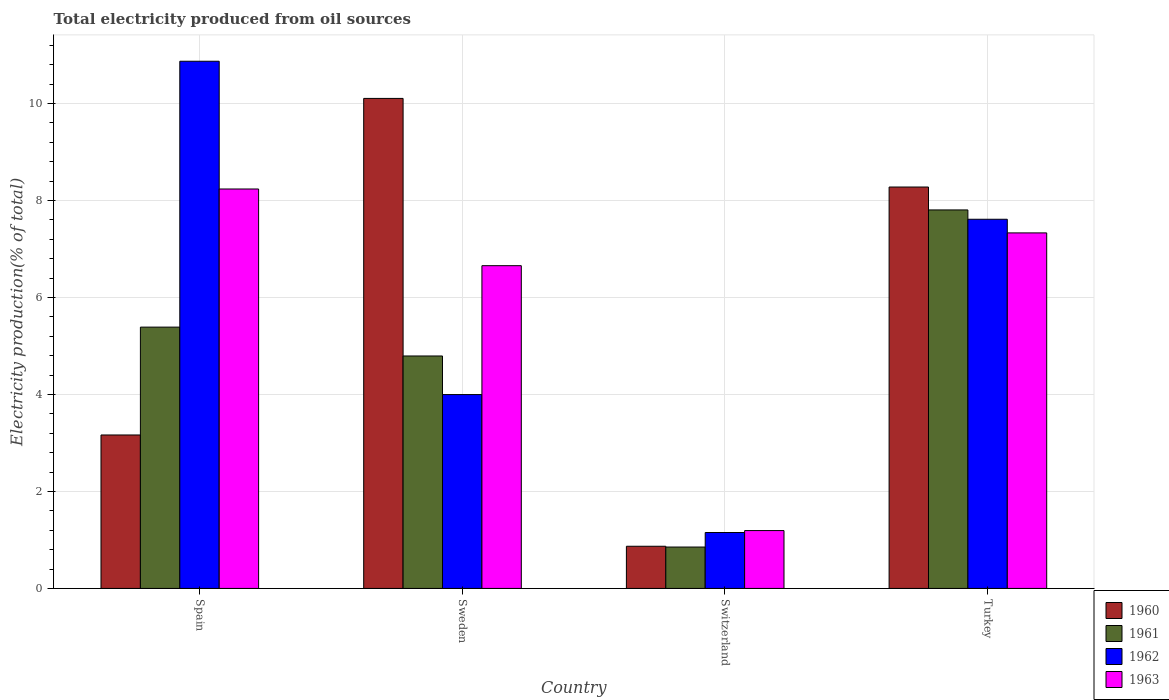How many different coloured bars are there?
Make the answer very short. 4. How many groups of bars are there?
Your answer should be compact. 4. How many bars are there on the 1st tick from the left?
Your response must be concise. 4. How many bars are there on the 3rd tick from the right?
Give a very brief answer. 4. What is the label of the 3rd group of bars from the left?
Make the answer very short. Switzerland. What is the total electricity produced in 1960 in Sweden?
Your answer should be very brief. 10.1. Across all countries, what is the maximum total electricity produced in 1961?
Provide a short and direct response. 7.8. Across all countries, what is the minimum total electricity produced in 1963?
Offer a terse response. 1.19. In which country was the total electricity produced in 1963 minimum?
Offer a terse response. Switzerland. What is the total total electricity produced in 1963 in the graph?
Provide a succinct answer. 23.42. What is the difference between the total electricity produced in 1962 in Spain and that in Turkey?
Ensure brevity in your answer.  3.26. What is the difference between the total electricity produced in 1960 in Switzerland and the total electricity produced in 1963 in Spain?
Your answer should be very brief. -7.37. What is the average total electricity produced in 1960 per country?
Your answer should be very brief. 5.6. What is the difference between the total electricity produced of/in 1962 and total electricity produced of/in 1963 in Turkey?
Your answer should be compact. 0.28. In how many countries, is the total electricity produced in 1962 greater than 4.4 %?
Provide a short and direct response. 2. What is the ratio of the total electricity produced in 1962 in Sweden to that in Switzerland?
Your answer should be very brief. 3.47. What is the difference between the highest and the second highest total electricity produced in 1961?
Give a very brief answer. -0.6. What is the difference between the highest and the lowest total electricity produced in 1960?
Your answer should be very brief. 9.23. In how many countries, is the total electricity produced in 1960 greater than the average total electricity produced in 1960 taken over all countries?
Provide a short and direct response. 2. What does the 4th bar from the left in Sweden represents?
Give a very brief answer. 1963. Is it the case that in every country, the sum of the total electricity produced in 1962 and total electricity produced in 1963 is greater than the total electricity produced in 1961?
Your answer should be compact. Yes. What is the difference between two consecutive major ticks on the Y-axis?
Provide a succinct answer. 2. Where does the legend appear in the graph?
Your answer should be very brief. Bottom right. How many legend labels are there?
Offer a very short reply. 4. How are the legend labels stacked?
Offer a terse response. Vertical. What is the title of the graph?
Provide a succinct answer. Total electricity produced from oil sources. Does "2002" appear as one of the legend labels in the graph?
Ensure brevity in your answer.  No. What is the Electricity production(% of total) of 1960 in Spain?
Your response must be concise. 3.16. What is the Electricity production(% of total) of 1961 in Spain?
Provide a succinct answer. 5.39. What is the Electricity production(% of total) in 1962 in Spain?
Your response must be concise. 10.87. What is the Electricity production(% of total) of 1963 in Spain?
Offer a terse response. 8.24. What is the Electricity production(% of total) in 1960 in Sweden?
Give a very brief answer. 10.1. What is the Electricity production(% of total) of 1961 in Sweden?
Offer a very short reply. 4.79. What is the Electricity production(% of total) in 1962 in Sweden?
Keep it short and to the point. 4. What is the Electricity production(% of total) in 1963 in Sweden?
Your answer should be very brief. 6.66. What is the Electricity production(% of total) in 1960 in Switzerland?
Provide a short and direct response. 0.87. What is the Electricity production(% of total) of 1961 in Switzerland?
Provide a succinct answer. 0.85. What is the Electricity production(% of total) in 1962 in Switzerland?
Ensure brevity in your answer.  1.15. What is the Electricity production(% of total) of 1963 in Switzerland?
Your answer should be compact. 1.19. What is the Electricity production(% of total) in 1960 in Turkey?
Offer a terse response. 8.28. What is the Electricity production(% of total) of 1961 in Turkey?
Your response must be concise. 7.8. What is the Electricity production(% of total) of 1962 in Turkey?
Your answer should be very brief. 7.61. What is the Electricity production(% of total) in 1963 in Turkey?
Your answer should be compact. 7.33. Across all countries, what is the maximum Electricity production(% of total) in 1960?
Provide a succinct answer. 10.1. Across all countries, what is the maximum Electricity production(% of total) of 1961?
Offer a terse response. 7.8. Across all countries, what is the maximum Electricity production(% of total) of 1962?
Your response must be concise. 10.87. Across all countries, what is the maximum Electricity production(% of total) in 1963?
Your answer should be compact. 8.24. Across all countries, what is the minimum Electricity production(% of total) in 1960?
Provide a short and direct response. 0.87. Across all countries, what is the minimum Electricity production(% of total) in 1961?
Your response must be concise. 0.85. Across all countries, what is the minimum Electricity production(% of total) of 1962?
Your answer should be compact. 1.15. Across all countries, what is the minimum Electricity production(% of total) in 1963?
Ensure brevity in your answer.  1.19. What is the total Electricity production(% of total) of 1960 in the graph?
Make the answer very short. 22.42. What is the total Electricity production(% of total) of 1961 in the graph?
Give a very brief answer. 18.84. What is the total Electricity production(% of total) of 1962 in the graph?
Offer a terse response. 23.63. What is the total Electricity production(% of total) in 1963 in the graph?
Offer a terse response. 23.42. What is the difference between the Electricity production(% of total) of 1960 in Spain and that in Sweden?
Offer a very short reply. -6.94. What is the difference between the Electricity production(% of total) of 1961 in Spain and that in Sweden?
Offer a very short reply. 0.6. What is the difference between the Electricity production(% of total) of 1962 in Spain and that in Sweden?
Your response must be concise. 6.87. What is the difference between the Electricity production(% of total) of 1963 in Spain and that in Sweden?
Ensure brevity in your answer.  1.58. What is the difference between the Electricity production(% of total) of 1960 in Spain and that in Switzerland?
Offer a very short reply. 2.29. What is the difference between the Electricity production(% of total) of 1961 in Spain and that in Switzerland?
Keep it short and to the point. 4.53. What is the difference between the Electricity production(% of total) in 1962 in Spain and that in Switzerland?
Ensure brevity in your answer.  9.72. What is the difference between the Electricity production(% of total) of 1963 in Spain and that in Switzerland?
Keep it short and to the point. 7.04. What is the difference between the Electricity production(% of total) in 1960 in Spain and that in Turkey?
Give a very brief answer. -5.11. What is the difference between the Electricity production(% of total) in 1961 in Spain and that in Turkey?
Offer a terse response. -2.42. What is the difference between the Electricity production(% of total) of 1962 in Spain and that in Turkey?
Provide a short and direct response. 3.26. What is the difference between the Electricity production(% of total) of 1963 in Spain and that in Turkey?
Your answer should be compact. 0.91. What is the difference between the Electricity production(% of total) of 1960 in Sweden and that in Switzerland?
Ensure brevity in your answer.  9.23. What is the difference between the Electricity production(% of total) of 1961 in Sweden and that in Switzerland?
Your answer should be very brief. 3.94. What is the difference between the Electricity production(% of total) of 1962 in Sweden and that in Switzerland?
Your answer should be very brief. 2.84. What is the difference between the Electricity production(% of total) in 1963 in Sweden and that in Switzerland?
Make the answer very short. 5.46. What is the difference between the Electricity production(% of total) of 1960 in Sweden and that in Turkey?
Your answer should be very brief. 1.83. What is the difference between the Electricity production(% of total) in 1961 in Sweden and that in Turkey?
Offer a very short reply. -3.01. What is the difference between the Electricity production(% of total) of 1962 in Sweden and that in Turkey?
Provide a short and direct response. -3.61. What is the difference between the Electricity production(% of total) of 1963 in Sweden and that in Turkey?
Make the answer very short. -0.68. What is the difference between the Electricity production(% of total) in 1960 in Switzerland and that in Turkey?
Ensure brevity in your answer.  -7.41. What is the difference between the Electricity production(% of total) in 1961 in Switzerland and that in Turkey?
Provide a succinct answer. -6.95. What is the difference between the Electricity production(% of total) of 1962 in Switzerland and that in Turkey?
Make the answer very short. -6.46. What is the difference between the Electricity production(% of total) in 1963 in Switzerland and that in Turkey?
Ensure brevity in your answer.  -6.14. What is the difference between the Electricity production(% of total) in 1960 in Spain and the Electricity production(% of total) in 1961 in Sweden?
Your response must be concise. -1.63. What is the difference between the Electricity production(% of total) of 1960 in Spain and the Electricity production(% of total) of 1962 in Sweden?
Provide a short and direct response. -0.83. What is the difference between the Electricity production(% of total) of 1960 in Spain and the Electricity production(% of total) of 1963 in Sweden?
Make the answer very short. -3.49. What is the difference between the Electricity production(% of total) of 1961 in Spain and the Electricity production(% of total) of 1962 in Sweden?
Your answer should be very brief. 1.39. What is the difference between the Electricity production(% of total) of 1961 in Spain and the Electricity production(% of total) of 1963 in Sweden?
Give a very brief answer. -1.27. What is the difference between the Electricity production(% of total) of 1962 in Spain and the Electricity production(% of total) of 1963 in Sweden?
Your response must be concise. 4.22. What is the difference between the Electricity production(% of total) in 1960 in Spain and the Electricity production(% of total) in 1961 in Switzerland?
Give a very brief answer. 2.31. What is the difference between the Electricity production(% of total) of 1960 in Spain and the Electricity production(% of total) of 1962 in Switzerland?
Provide a short and direct response. 2.01. What is the difference between the Electricity production(% of total) of 1960 in Spain and the Electricity production(% of total) of 1963 in Switzerland?
Offer a terse response. 1.97. What is the difference between the Electricity production(% of total) in 1961 in Spain and the Electricity production(% of total) in 1962 in Switzerland?
Ensure brevity in your answer.  4.24. What is the difference between the Electricity production(% of total) of 1961 in Spain and the Electricity production(% of total) of 1963 in Switzerland?
Keep it short and to the point. 4.2. What is the difference between the Electricity production(% of total) of 1962 in Spain and the Electricity production(% of total) of 1963 in Switzerland?
Offer a terse response. 9.68. What is the difference between the Electricity production(% of total) in 1960 in Spain and the Electricity production(% of total) in 1961 in Turkey?
Offer a very short reply. -4.64. What is the difference between the Electricity production(% of total) in 1960 in Spain and the Electricity production(% of total) in 1962 in Turkey?
Your answer should be compact. -4.45. What is the difference between the Electricity production(% of total) of 1960 in Spain and the Electricity production(% of total) of 1963 in Turkey?
Provide a succinct answer. -4.17. What is the difference between the Electricity production(% of total) in 1961 in Spain and the Electricity production(% of total) in 1962 in Turkey?
Keep it short and to the point. -2.22. What is the difference between the Electricity production(% of total) of 1961 in Spain and the Electricity production(% of total) of 1963 in Turkey?
Your response must be concise. -1.94. What is the difference between the Electricity production(% of total) of 1962 in Spain and the Electricity production(% of total) of 1963 in Turkey?
Your response must be concise. 3.54. What is the difference between the Electricity production(% of total) in 1960 in Sweden and the Electricity production(% of total) in 1961 in Switzerland?
Provide a succinct answer. 9.25. What is the difference between the Electricity production(% of total) of 1960 in Sweden and the Electricity production(% of total) of 1962 in Switzerland?
Your answer should be very brief. 8.95. What is the difference between the Electricity production(% of total) of 1960 in Sweden and the Electricity production(% of total) of 1963 in Switzerland?
Keep it short and to the point. 8.91. What is the difference between the Electricity production(% of total) of 1961 in Sweden and the Electricity production(% of total) of 1962 in Switzerland?
Keep it short and to the point. 3.64. What is the difference between the Electricity production(% of total) of 1961 in Sweden and the Electricity production(% of total) of 1963 in Switzerland?
Your answer should be compact. 3.6. What is the difference between the Electricity production(% of total) in 1962 in Sweden and the Electricity production(% of total) in 1963 in Switzerland?
Your answer should be very brief. 2.8. What is the difference between the Electricity production(% of total) in 1960 in Sweden and the Electricity production(% of total) in 1961 in Turkey?
Give a very brief answer. 2.3. What is the difference between the Electricity production(% of total) in 1960 in Sweden and the Electricity production(% of total) in 1962 in Turkey?
Give a very brief answer. 2.49. What is the difference between the Electricity production(% of total) of 1960 in Sweden and the Electricity production(% of total) of 1963 in Turkey?
Your answer should be very brief. 2.77. What is the difference between the Electricity production(% of total) in 1961 in Sweden and the Electricity production(% of total) in 1962 in Turkey?
Offer a terse response. -2.82. What is the difference between the Electricity production(% of total) in 1961 in Sweden and the Electricity production(% of total) in 1963 in Turkey?
Your answer should be very brief. -2.54. What is the difference between the Electricity production(% of total) in 1962 in Sweden and the Electricity production(% of total) in 1963 in Turkey?
Ensure brevity in your answer.  -3.33. What is the difference between the Electricity production(% of total) in 1960 in Switzerland and the Electricity production(% of total) in 1961 in Turkey?
Make the answer very short. -6.94. What is the difference between the Electricity production(% of total) of 1960 in Switzerland and the Electricity production(% of total) of 1962 in Turkey?
Keep it short and to the point. -6.74. What is the difference between the Electricity production(% of total) in 1960 in Switzerland and the Electricity production(% of total) in 1963 in Turkey?
Keep it short and to the point. -6.46. What is the difference between the Electricity production(% of total) of 1961 in Switzerland and the Electricity production(% of total) of 1962 in Turkey?
Provide a short and direct response. -6.76. What is the difference between the Electricity production(% of total) of 1961 in Switzerland and the Electricity production(% of total) of 1963 in Turkey?
Offer a very short reply. -6.48. What is the difference between the Electricity production(% of total) of 1962 in Switzerland and the Electricity production(% of total) of 1963 in Turkey?
Your response must be concise. -6.18. What is the average Electricity production(% of total) in 1960 per country?
Keep it short and to the point. 5.6. What is the average Electricity production(% of total) of 1961 per country?
Your answer should be compact. 4.71. What is the average Electricity production(% of total) of 1962 per country?
Your answer should be compact. 5.91. What is the average Electricity production(% of total) in 1963 per country?
Make the answer very short. 5.85. What is the difference between the Electricity production(% of total) of 1960 and Electricity production(% of total) of 1961 in Spain?
Keep it short and to the point. -2.22. What is the difference between the Electricity production(% of total) of 1960 and Electricity production(% of total) of 1962 in Spain?
Offer a very short reply. -7.71. What is the difference between the Electricity production(% of total) of 1960 and Electricity production(% of total) of 1963 in Spain?
Make the answer very short. -5.07. What is the difference between the Electricity production(% of total) of 1961 and Electricity production(% of total) of 1962 in Spain?
Offer a very short reply. -5.48. What is the difference between the Electricity production(% of total) of 1961 and Electricity production(% of total) of 1963 in Spain?
Offer a terse response. -2.85. What is the difference between the Electricity production(% of total) in 1962 and Electricity production(% of total) in 1963 in Spain?
Your answer should be very brief. 2.63. What is the difference between the Electricity production(% of total) of 1960 and Electricity production(% of total) of 1961 in Sweden?
Your response must be concise. 5.31. What is the difference between the Electricity production(% of total) in 1960 and Electricity production(% of total) in 1962 in Sweden?
Offer a terse response. 6.11. What is the difference between the Electricity production(% of total) in 1960 and Electricity production(% of total) in 1963 in Sweden?
Keep it short and to the point. 3.45. What is the difference between the Electricity production(% of total) in 1961 and Electricity production(% of total) in 1962 in Sweden?
Offer a terse response. 0.8. What is the difference between the Electricity production(% of total) of 1961 and Electricity production(% of total) of 1963 in Sweden?
Your response must be concise. -1.86. What is the difference between the Electricity production(% of total) of 1962 and Electricity production(% of total) of 1963 in Sweden?
Make the answer very short. -2.66. What is the difference between the Electricity production(% of total) in 1960 and Electricity production(% of total) in 1961 in Switzerland?
Your response must be concise. 0.02. What is the difference between the Electricity production(% of total) in 1960 and Electricity production(% of total) in 1962 in Switzerland?
Offer a terse response. -0.28. What is the difference between the Electricity production(% of total) in 1960 and Electricity production(% of total) in 1963 in Switzerland?
Provide a short and direct response. -0.32. What is the difference between the Electricity production(% of total) of 1961 and Electricity production(% of total) of 1962 in Switzerland?
Make the answer very short. -0.3. What is the difference between the Electricity production(% of total) in 1961 and Electricity production(% of total) in 1963 in Switzerland?
Provide a short and direct response. -0.34. What is the difference between the Electricity production(% of total) of 1962 and Electricity production(% of total) of 1963 in Switzerland?
Keep it short and to the point. -0.04. What is the difference between the Electricity production(% of total) of 1960 and Electricity production(% of total) of 1961 in Turkey?
Your answer should be compact. 0.47. What is the difference between the Electricity production(% of total) of 1960 and Electricity production(% of total) of 1962 in Turkey?
Ensure brevity in your answer.  0.66. What is the difference between the Electricity production(% of total) in 1960 and Electricity production(% of total) in 1963 in Turkey?
Provide a short and direct response. 0.95. What is the difference between the Electricity production(% of total) of 1961 and Electricity production(% of total) of 1962 in Turkey?
Your answer should be very brief. 0.19. What is the difference between the Electricity production(% of total) in 1961 and Electricity production(% of total) in 1963 in Turkey?
Provide a short and direct response. 0.47. What is the difference between the Electricity production(% of total) in 1962 and Electricity production(% of total) in 1963 in Turkey?
Your answer should be very brief. 0.28. What is the ratio of the Electricity production(% of total) of 1960 in Spain to that in Sweden?
Your answer should be compact. 0.31. What is the ratio of the Electricity production(% of total) of 1961 in Spain to that in Sweden?
Keep it short and to the point. 1.12. What is the ratio of the Electricity production(% of total) in 1962 in Spain to that in Sweden?
Provide a succinct answer. 2.72. What is the ratio of the Electricity production(% of total) of 1963 in Spain to that in Sweden?
Provide a succinct answer. 1.24. What is the ratio of the Electricity production(% of total) in 1960 in Spain to that in Switzerland?
Make the answer very short. 3.64. What is the ratio of the Electricity production(% of total) in 1961 in Spain to that in Switzerland?
Offer a terse response. 6.31. What is the ratio of the Electricity production(% of total) in 1962 in Spain to that in Switzerland?
Make the answer very short. 9.43. What is the ratio of the Electricity production(% of total) in 1963 in Spain to that in Switzerland?
Provide a short and direct response. 6.9. What is the ratio of the Electricity production(% of total) in 1960 in Spain to that in Turkey?
Offer a terse response. 0.38. What is the ratio of the Electricity production(% of total) in 1961 in Spain to that in Turkey?
Your answer should be compact. 0.69. What is the ratio of the Electricity production(% of total) in 1962 in Spain to that in Turkey?
Ensure brevity in your answer.  1.43. What is the ratio of the Electricity production(% of total) of 1963 in Spain to that in Turkey?
Provide a succinct answer. 1.12. What is the ratio of the Electricity production(% of total) in 1960 in Sweden to that in Switzerland?
Offer a terse response. 11.62. What is the ratio of the Electricity production(% of total) in 1961 in Sweden to that in Switzerland?
Your answer should be very brief. 5.62. What is the ratio of the Electricity production(% of total) in 1962 in Sweden to that in Switzerland?
Your answer should be very brief. 3.47. What is the ratio of the Electricity production(% of total) of 1963 in Sweden to that in Switzerland?
Your answer should be very brief. 5.58. What is the ratio of the Electricity production(% of total) in 1960 in Sweden to that in Turkey?
Ensure brevity in your answer.  1.22. What is the ratio of the Electricity production(% of total) of 1961 in Sweden to that in Turkey?
Keep it short and to the point. 0.61. What is the ratio of the Electricity production(% of total) in 1962 in Sweden to that in Turkey?
Provide a short and direct response. 0.53. What is the ratio of the Electricity production(% of total) of 1963 in Sweden to that in Turkey?
Provide a short and direct response. 0.91. What is the ratio of the Electricity production(% of total) in 1960 in Switzerland to that in Turkey?
Make the answer very short. 0.11. What is the ratio of the Electricity production(% of total) of 1961 in Switzerland to that in Turkey?
Ensure brevity in your answer.  0.11. What is the ratio of the Electricity production(% of total) in 1962 in Switzerland to that in Turkey?
Make the answer very short. 0.15. What is the ratio of the Electricity production(% of total) of 1963 in Switzerland to that in Turkey?
Your answer should be compact. 0.16. What is the difference between the highest and the second highest Electricity production(% of total) in 1960?
Your answer should be compact. 1.83. What is the difference between the highest and the second highest Electricity production(% of total) in 1961?
Offer a terse response. 2.42. What is the difference between the highest and the second highest Electricity production(% of total) of 1962?
Provide a short and direct response. 3.26. What is the difference between the highest and the second highest Electricity production(% of total) in 1963?
Make the answer very short. 0.91. What is the difference between the highest and the lowest Electricity production(% of total) in 1960?
Give a very brief answer. 9.23. What is the difference between the highest and the lowest Electricity production(% of total) of 1961?
Keep it short and to the point. 6.95. What is the difference between the highest and the lowest Electricity production(% of total) in 1962?
Give a very brief answer. 9.72. What is the difference between the highest and the lowest Electricity production(% of total) of 1963?
Provide a short and direct response. 7.04. 